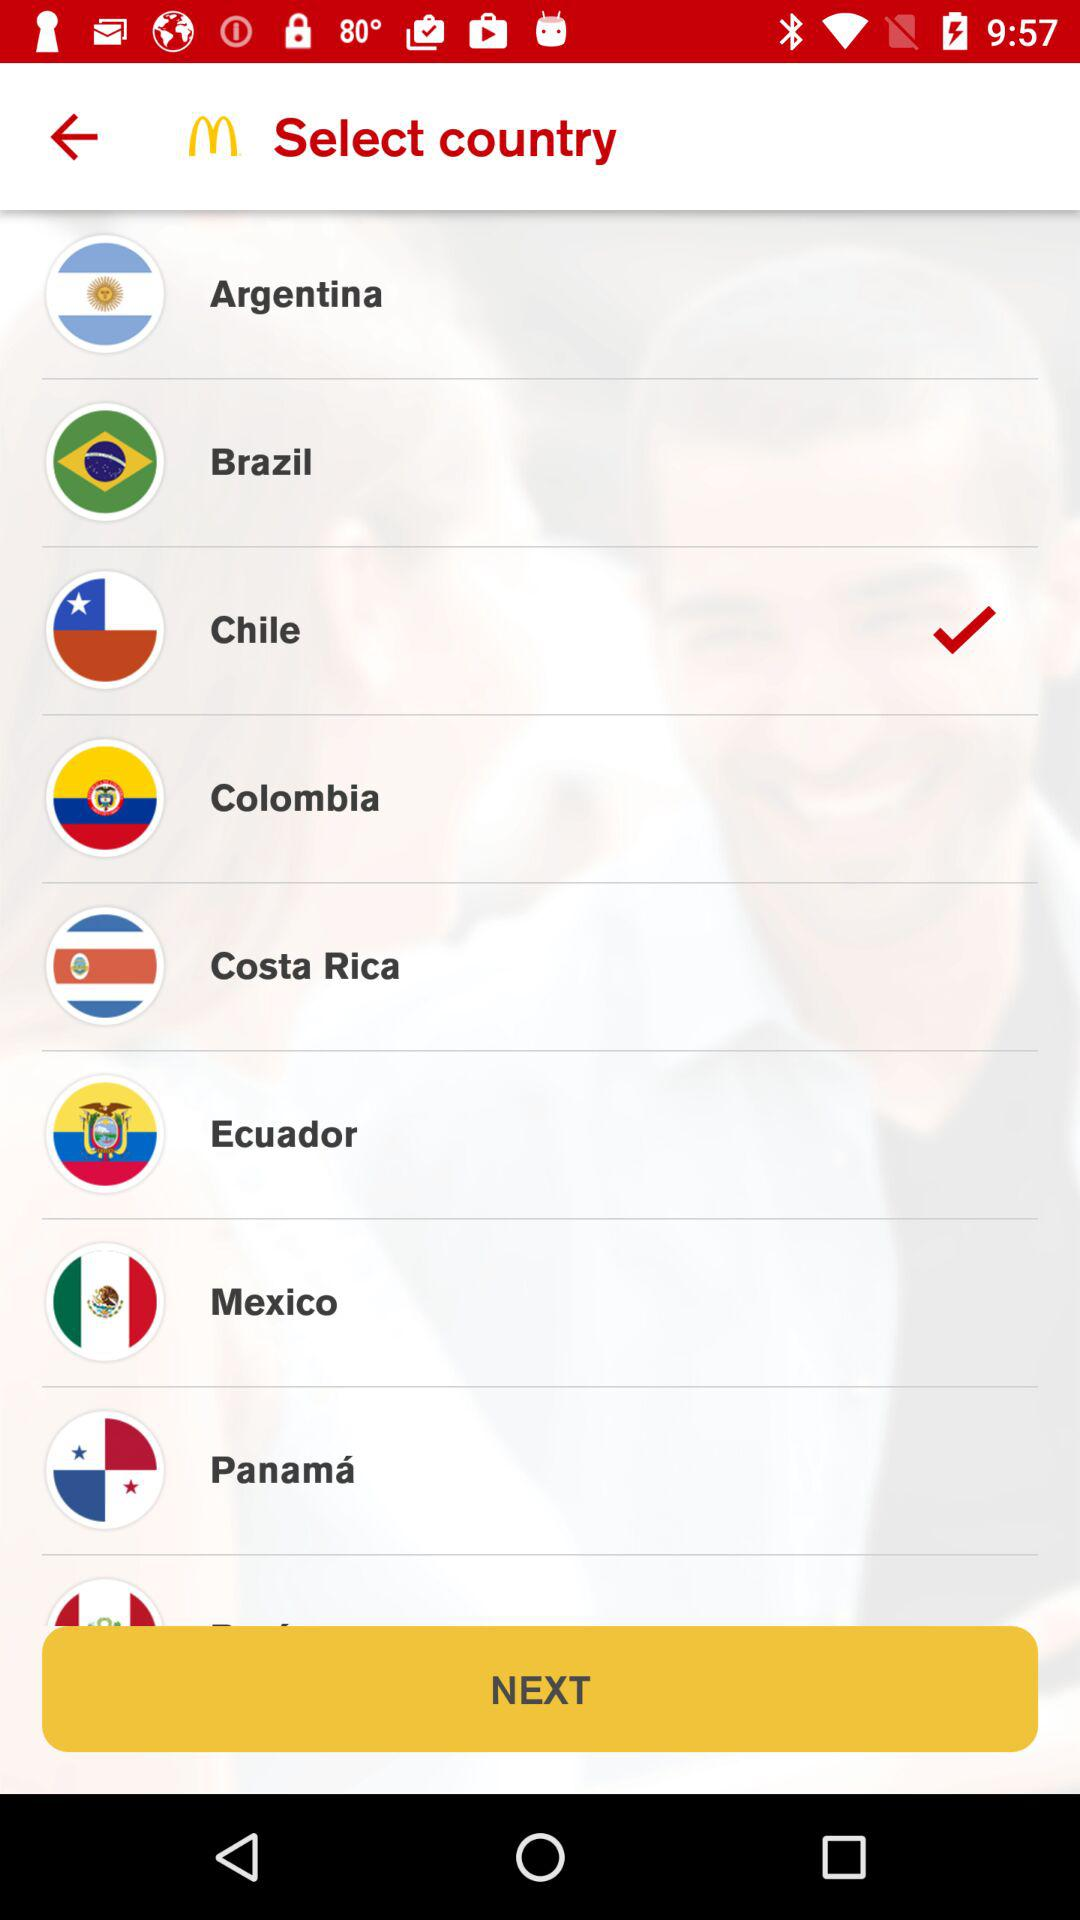What is the app name? The app name is "McDonald's". 